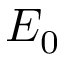Convert formula to latex. <formula><loc_0><loc_0><loc_500><loc_500>E _ { 0 }</formula> 